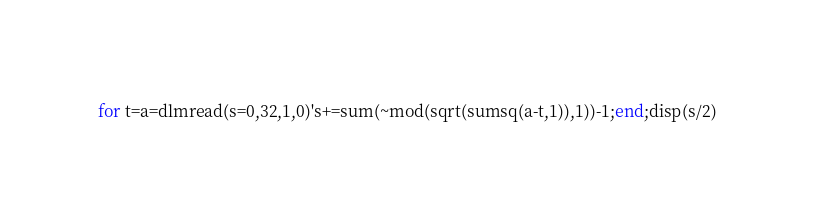<code> <loc_0><loc_0><loc_500><loc_500><_Octave_>for t=a=dlmread(s=0,32,1,0)'s+=sum(~mod(sqrt(sumsq(a-t,1)),1))-1;end;disp(s/2)</code> 